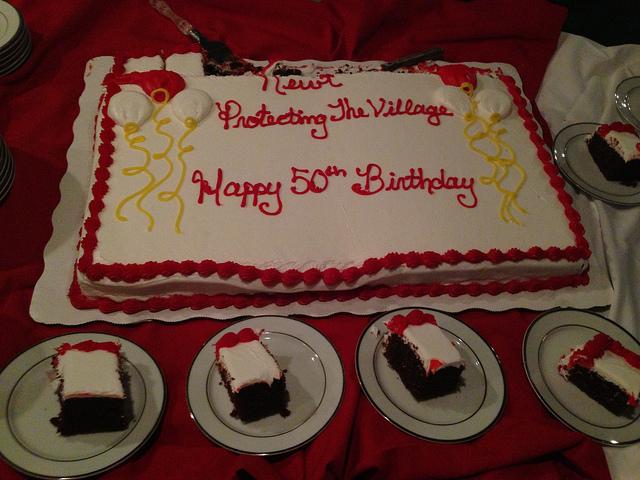Is this a breakfast?
Short answer required. No. What desert is sliced?
Be succinct. Cake. What kind of math is this?
Give a very brief answer. Age. How many plates in this stack?
Short answer required. 5. What shape are these items?
Be succinct. Rectangular. How many cakes are sliced?
Concise answer only. 5. Are the sweets all the same?
Be succinct. Yes. Are these edible?
Concise answer only. Yes. How many pieces of cake are on a plate?
Give a very brief answer. 1. What is written on the plate?
Give a very brief answer. Newt protecting village happy 50th birthday. What color is the cake?
Be succinct. White and red. What is the flavor of the cake?
Be succinct. Chocolate. How many smalls dishes are there?
Keep it brief. 6. What does it say in red?
Answer briefly. Happy 50th birthday. What color are the cakes?
Concise answer only. Brown. Have any slices been taken out yet?
Concise answer only. Yes. Who will be missed?
Short answer required. Newt. What letters are on the cup?
Be succinct. Red. Is this a cake for a kid's birthday?
Answer briefly. No. Is this a color or black and white photo?
Write a very short answer. Color. Will these foods likely be assembled into a sandwich?
Give a very brief answer. No. Is this a child's birthday cake?
Answer briefly. No. What is the cake in celebration of?
Keep it brief. Birthday. Is this cake patriotic?
Short answer required. No. Is this real cake?
Keep it brief. Yes. Who is having a birthday?
Concise answer only. Newt. How old is John today?
Be succinct. 50. What is this?
Keep it brief. Cake. How many cut slices of cake are shown?
Concise answer only. 5. What is the theme of the party?
Keep it brief. Birthday. Is this a silver tray?
Answer briefly. No. What color are the plates?
Be succinct. White. Is there chocolate cake on the table?
Write a very short answer. Yes. What number is on the cake?
Keep it brief. 50. What does the bigger cake say?
Give a very brief answer. Protecting village happy 50th birthday. What is the cake for?
Be succinct. Birthday. How many bowls are on the mat?
Concise answer only. 0. What color is the ribbon?
Give a very brief answer. Red. Is this cake for an adult?
Quick response, please. Yes. What type of food on the right of the plate?
Write a very short answer. Cake. What is the theme of the cake?
Keep it brief. Birthday. What is on the napkin?
Write a very short answer. Plate. How many items are shown?
Concise answer only. 6. What is the cake shaped like?
Short answer required. Rectangle. 